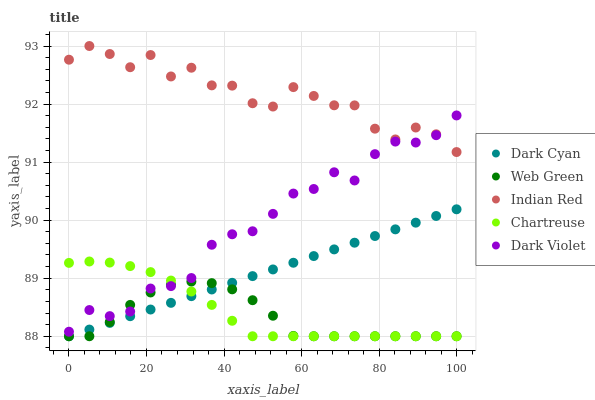Does Web Green have the minimum area under the curve?
Answer yes or no. Yes. Does Indian Red have the maximum area under the curve?
Answer yes or no. Yes. Does Chartreuse have the minimum area under the curve?
Answer yes or no. No. Does Chartreuse have the maximum area under the curve?
Answer yes or no. No. Is Dark Cyan the smoothest?
Answer yes or no. Yes. Is Indian Red the roughest?
Answer yes or no. Yes. Is Chartreuse the smoothest?
Answer yes or no. No. Is Chartreuse the roughest?
Answer yes or no. No. Does Dark Cyan have the lowest value?
Answer yes or no. Yes. Does Dark Violet have the lowest value?
Answer yes or no. No. Does Indian Red have the highest value?
Answer yes or no. Yes. Does Chartreuse have the highest value?
Answer yes or no. No. Is Dark Cyan less than Dark Violet?
Answer yes or no. Yes. Is Indian Red greater than Chartreuse?
Answer yes or no. Yes. Does Chartreuse intersect Web Green?
Answer yes or no. Yes. Is Chartreuse less than Web Green?
Answer yes or no. No. Is Chartreuse greater than Web Green?
Answer yes or no. No. Does Dark Cyan intersect Dark Violet?
Answer yes or no. No. 